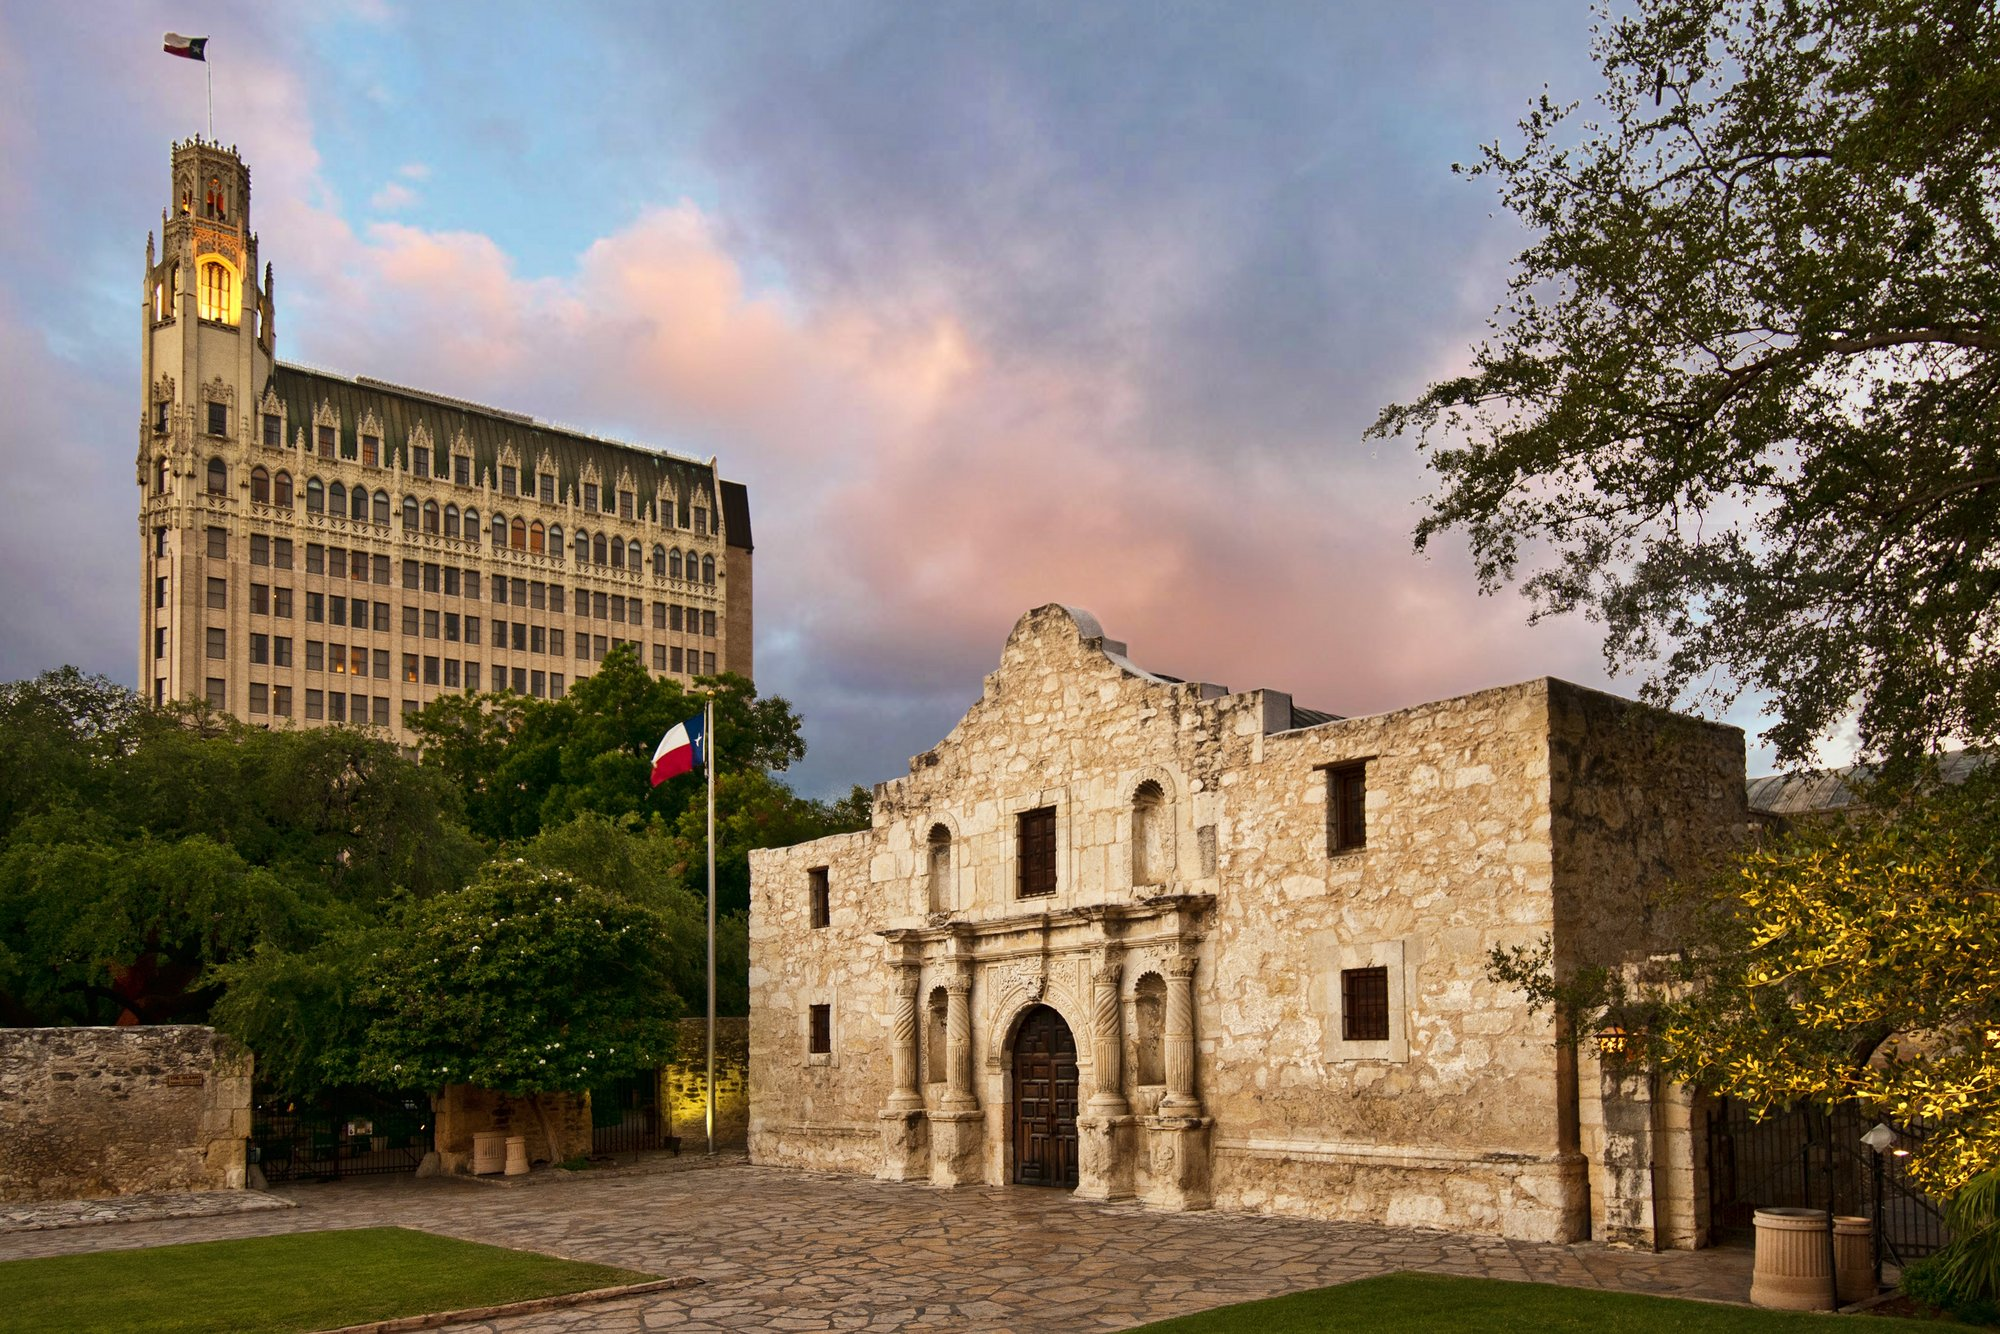Tell me more about the significance of the Alamo seen in the image. The Alamo, featured in the image, is a critical historical site in the United States, particularly in Texan history. Originally a mission and fortress, the Alamo played a pivotal role during the Texas Revolution. In 1836, the Battle of the Alamo became an iconic moment when a small group of Texan defenders held out for 13 days against the Centralist army of General Santa Anna. The phrase 'Remember the Alamo' became a rallying cry for Texas independence. Today, it stands as a symbol of bravery and resistance, and is a cherished heritage site visited by millions each year. 